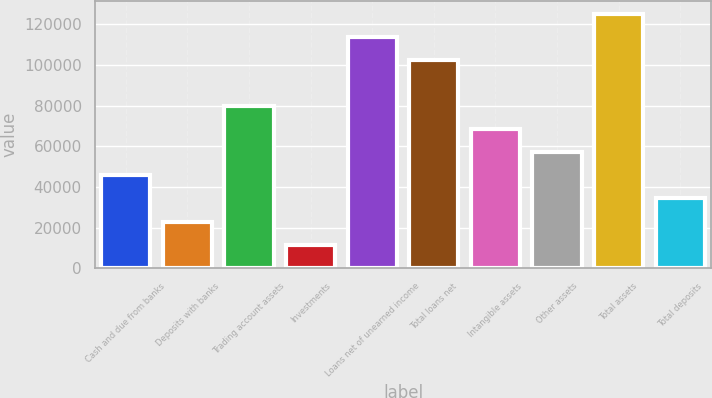Convert chart. <chart><loc_0><loc_0><loc_500><loc_500><bar_chart><fcel>Cash and due from banks<fcel>Deposits with banks<fcel>Trading account assets<fcel>Investments<fcel>Loans net of unearned income<fcel>Total loans net<fcel>Intangible assets<fcel>Other assets<fcel>Total assets<fcel>Total deposits<nl><fcel>45670.4<fcel>22956.2<fcel>79741.7<fcel>11599.1<fcel>113813<fcel>102456<fcel>68384.6<fcel>57027.5<fcel>125170<fcel>34313.3<nl></chart> 